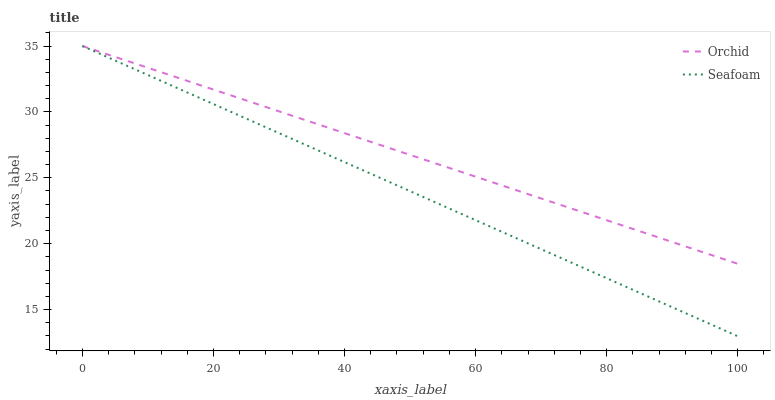Does Seafoam have the minimum area under the curve?
Answer yes or no. Yes. Does Orchid have the maximum area under the curve?
Answer yes or no. Yes. Does Orchid have the minimum area under the curve?
Answer yes or no. No. Is Seafoam the smoothest?
Answer yes or no. Yes. Is Orchid the roughest?
Answer yes or no. Yes. Is Orchid the smoothest?
Answer yes or no. No. Does Seafoam have the lowest value?
Answer yes or no. Yes. Does Orchid have the lowest value?
Answer yes or no. No. Does Orchid have the highest value?
Answer yes or no. Yes. Does Seafoam intersect Orchid?
Answer yes or no. Yes. Is Seafoam less than Orchid?
Answer yes or no. No. Is Seafoam greater than Orchid?
Answer yes or no. No. 